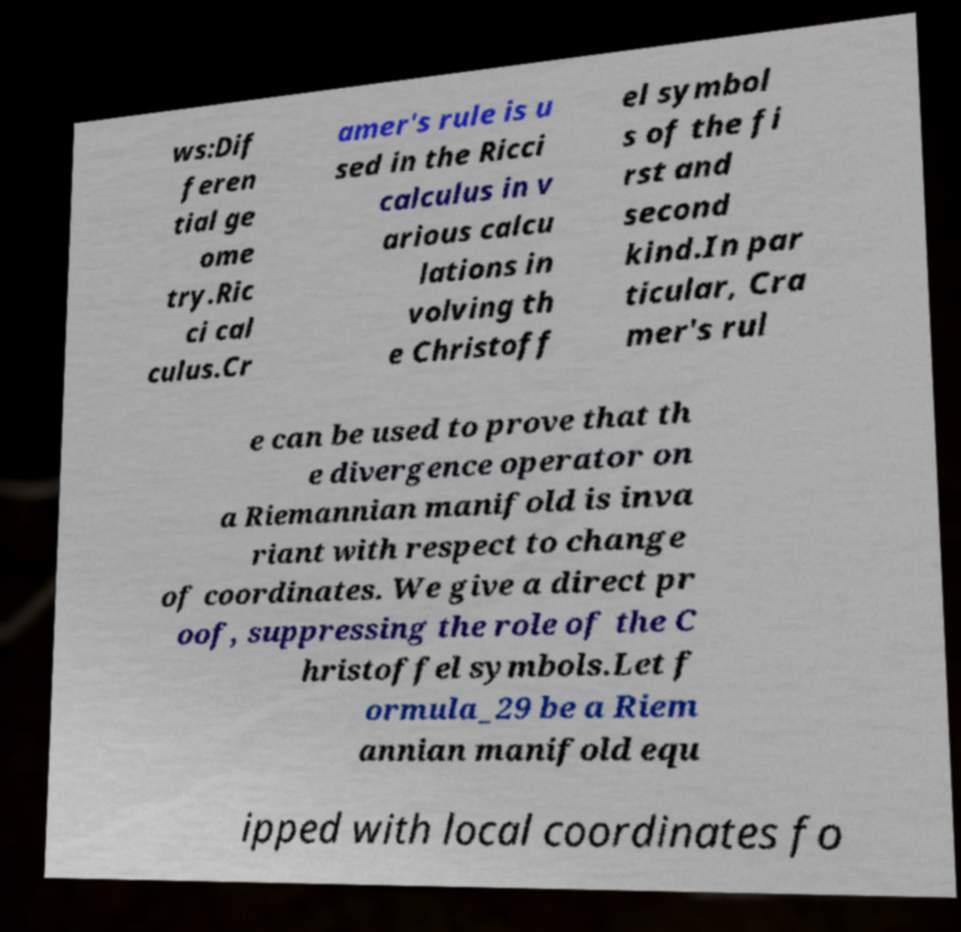Can you read and provide the text displayed in the image?This photo seems to have some interesting text. Can you extract and type it out for me? ws:Dif feren tial ge ome try.Ric ci cal culus.Cr amer's rule is u sed in the Ricci calculus in v arious calcu lations in volving th e Christoff el symbol s of the fi rst and second kind.In par ticular, Cra mer's rul e can be used to prove that th e divergence operator on a Riemannian manifold is inva riant with respect to change of coordinates. We give a direct pr oof, suppressing the role of the C hristoffel symbols.Let f ormula_29 be a Riem annian manifold equ ipped with local coordinates fo 